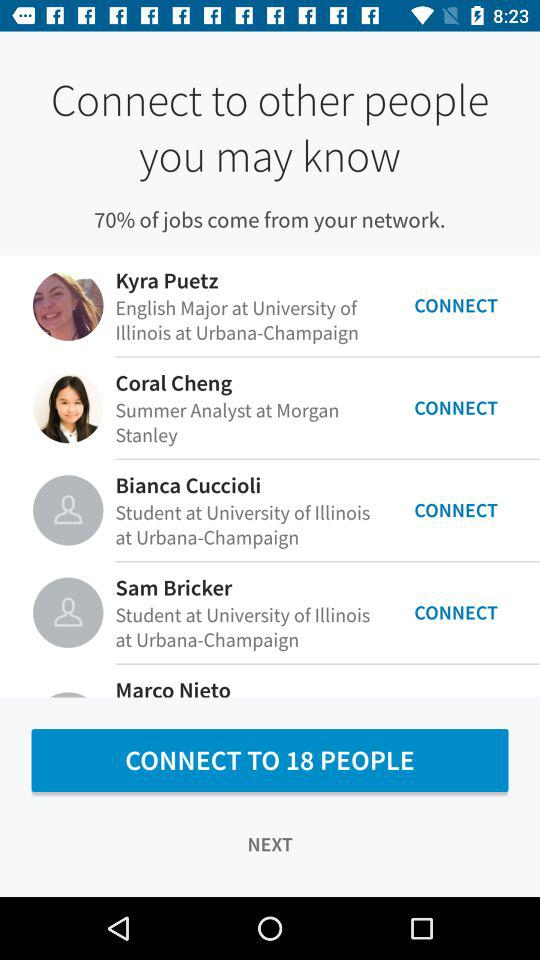How many people are from the University of Illinois at Urbana-Champaign?
Answer the question using a single word or phrase. 3 